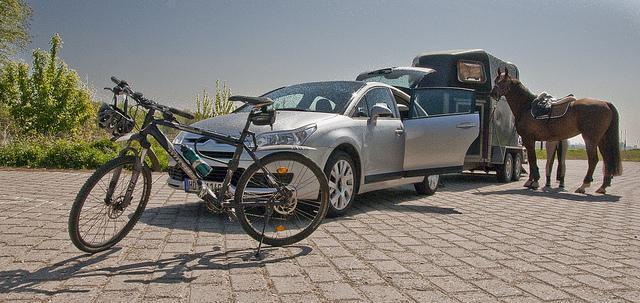How many people are wearing blue?
Give a very brief answer. 0. 